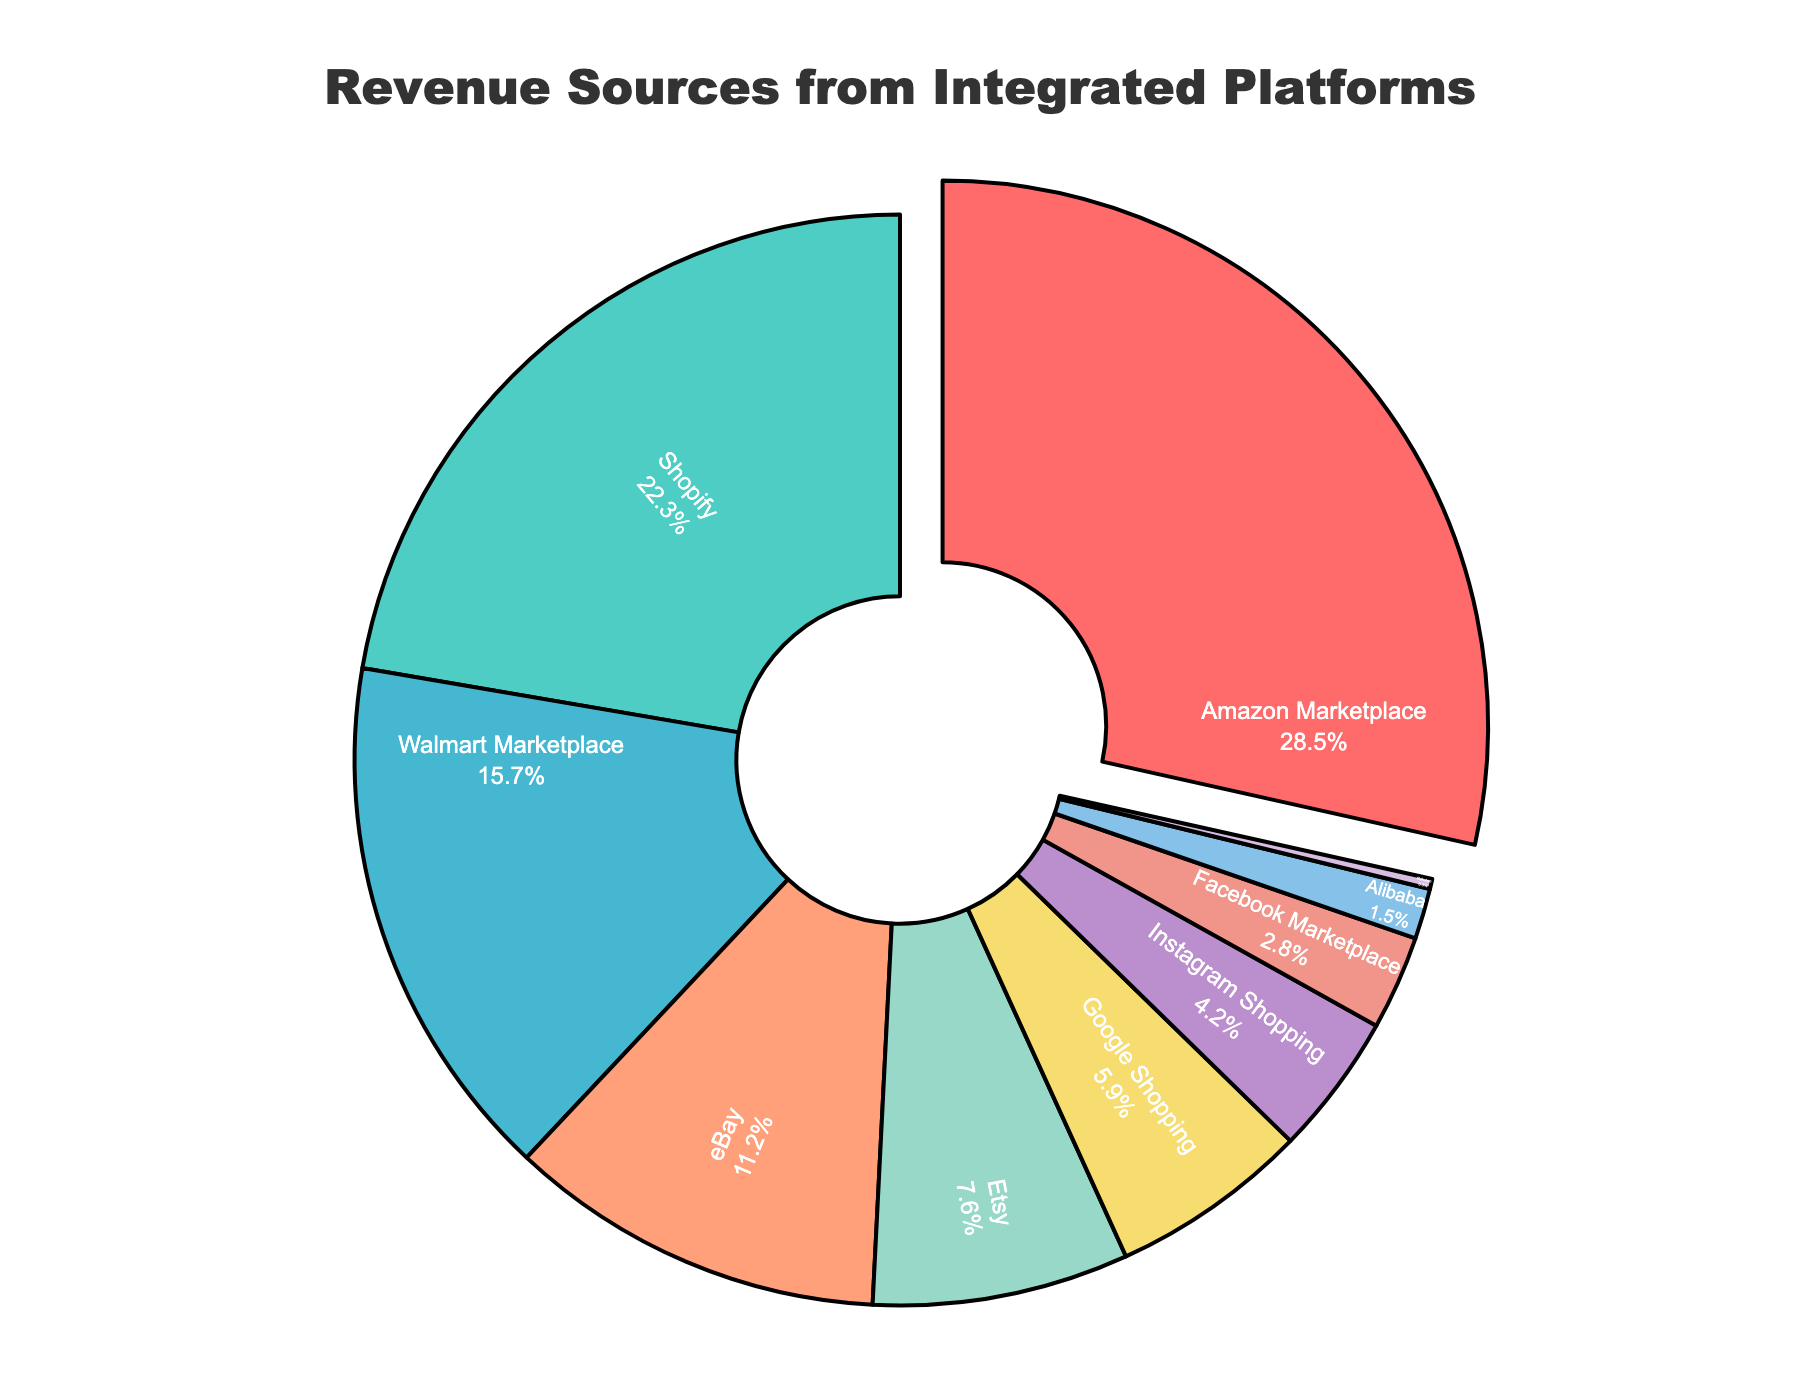What's the largest revenue source for the company? The red section of the pie chart represents Amazon Marketplace, which is the largest section and has the highest percentage at 28.5%.
Answer: Amazon Marketplace Which platform contributes to the smallest portion of revenue? The smallest section of the pie chart is colored in light purple and represents Rakuten with a revenue percentage of 0.3%.
Answer: Rakuten How much higher is the revenue percentage of Amazon Marketplace compared to Shopify? Amazon Marketplace has a revenue percentage of 28.5%, and Shopify has 22.3%. The difference between them is 28.5% - 22.3% = 6.2%.
Answer: 6.2% Which platforms contribute more than 20% to the revenue? Amazon Marketplace (28.5%) and Shopify (22.3%) are the only platforms that contribute more than 20% to the revenue, as indicated by their larger sections in the pie chart.
Answer: Amazon Marketplace, Shopify What is the combined revenue percentage of Walmart Marketplace and eBay? Walmart Marketplace contributes 15.7% and eBay contributes 11.2%. Their combined revenue percentage is 15.7% + 11.2% = 26.9%.
Answer: 26.9% What color is used to represent the revenue from Instagram Shopping? The section representing Instagram Shopping is colored in dark pink based on the visual attribute of the pie chart.
Answer: Dark Pink Which platform's section is slightly pulled out from the pie chart? The Amazon Marketplace's section is slightly pulled out, indicating it has the highest revenue percentage of 28.5%.
Answer: Amazon Marketplace How does the size of the Facebook Marketplace section compare to Google Shopping? Facebook Marketplace's section is smaller than Google Shopping with Facebook having 2.8% and Google Shopping having 5.9%.
Answer: Facebook Marketplace is smaller What is the average revenue percentage of Etsy, Google Shopping, and Instagram Shopping? Etsy: 7.6%, Google Shopping: 5.9%, Instagram Shopping: 4.2%. The average is (7.6 + 5.9 + 4.2) / 3 = 5.9%.
Answer: 5.9% What portion of the revenue do Etsy and Facebook Marketplace contribute together? Etsy contributes 7.6% and Facebook Marketplace contributes 2.8%. Their combined contribution is 7.6% + 2.8% = 10.4%.
Answer: 10.4% 